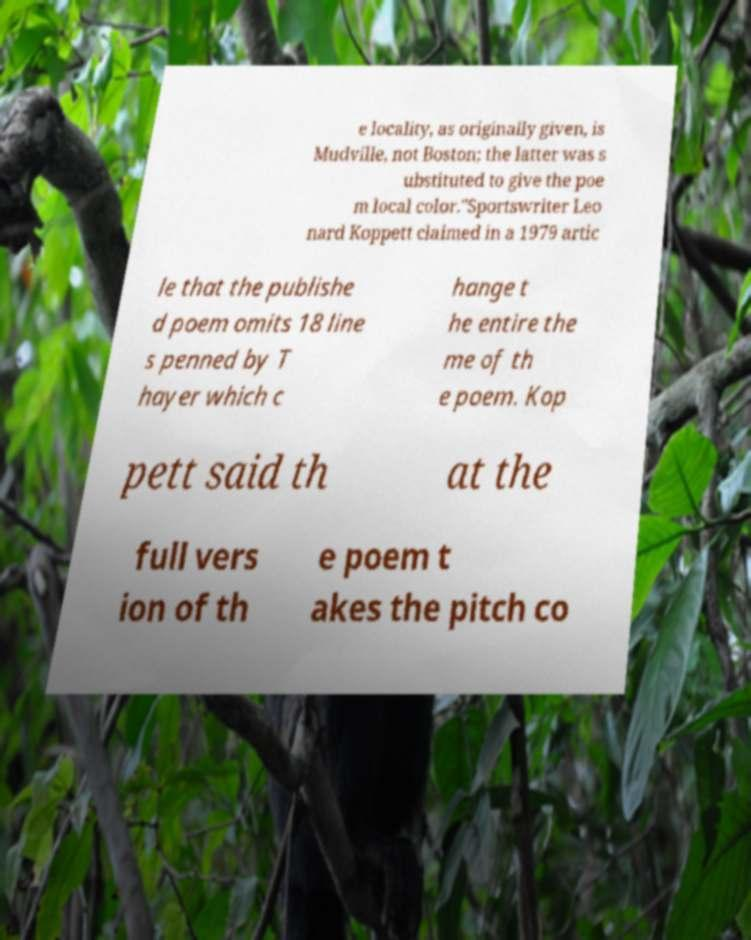Can you read and provide the text displayed in the image?This photo seems to have some interesting text. Can you extract and type it out for me? e locality, as originally given, is Mudville, not Boston; the latter was s ubstituted to give the poe m local color."Sportswriter Leo nard Koppett claimed in a 1979 artic le that the publishe d poem omits 18 line s penned by T hayer which c hange t he entire the me of th e poem. Kop pett said th at the full vers ion of th e poem t akes the pitch co 